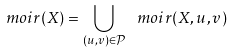Convert formula to latex. <formula><loc_0><loc_0><loc_500><loc_500>\ m o i r ( X ) = \bigcup _ { ( u , v ) \in \mathcal { P } } \ m o i r ( X , u , v )</formula> 